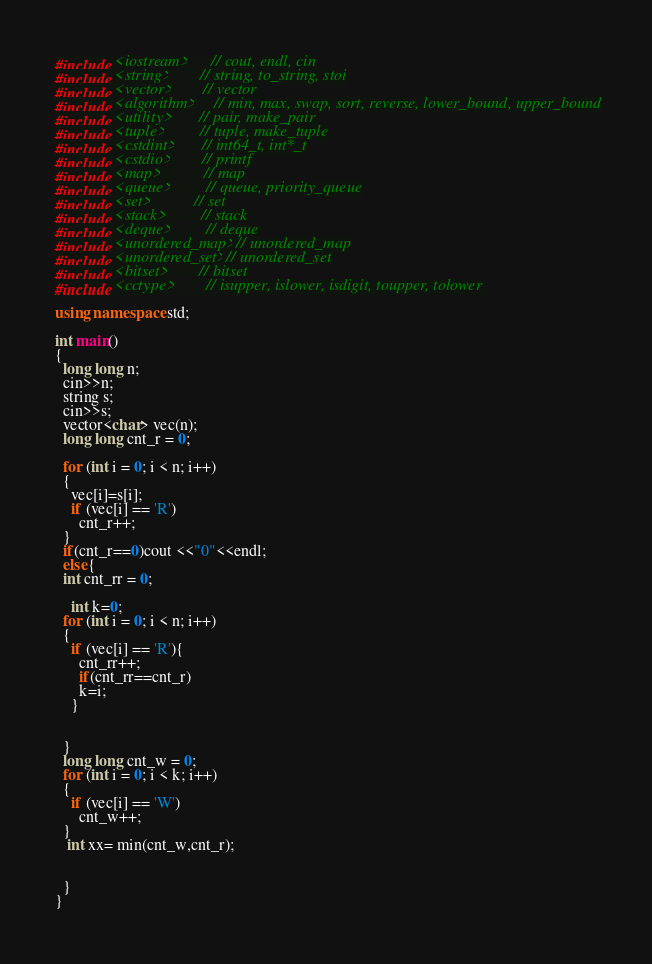<code> <loc_0><loc_0><loc_500><loc_500><_C++_>#include <iostream>      // cout, endl, cin
#include <string>        // string, to_string, stoi
#include <vector>        // vector
#include <algorithm>     // min, max, swap, sort, reverse, lower_bound, upper_bound
#include <utility>       // pair, make_pair
#include <tuple>         // tuple, make_tuple
#include <cstdint>       // int64_t, int*_t
#include <cstdio>        // printf
#include <map>           // map
#include <queue>         // queue, priority_queue
#include <set>           // set
#include <stack>         // stack
#include <deque>         // deque
#include <unordered_map> // unordered_map
#include <unordered_set> // unordered_set
#include <bitset>        // bitset
#include <cctype>        // isupper, islower, isdigit, toupper, tolower

using namespace std;

int main()
{
  long long n;
  cin>>n;
  string s;
  cin>>s;
  vector<char> vec(n);
  long long cnt_r = 0;
  
  for (int i = 0; i < n; i++)
  {
    vec[i]=s[i];
    if (vec[i] == 'R')
      cnt_r++;
  }
  if(cnt_r==0)cout <<"0"<<endl;
  else{
  int cnt_rr = 0;

    int k=0;
  for (int i = 0; i < n; i++)
  {
    if (vec[i] == 'R'){
      cnt_rr++;
      if(cnt_rr==cnt_r)
      k=i;
    }
  
    
  }
  long long cnt_w = 0;
  for (int i = 0; i < k; i++)
  {
    if (vec[i] == 'W')
      cnt_w++;
  }
   int xx= min(cnt_w,cnt_r);
  
    
  }
}
</code> 